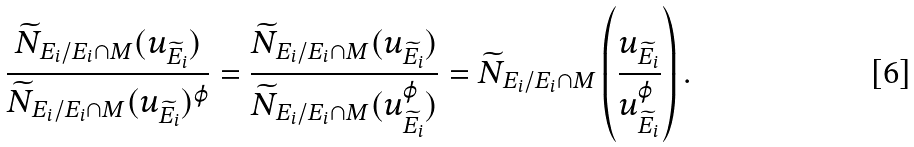<formula> <loc_0><loc_0><loc_500><loc_500>\frac { \widetilde { N } _ { E _ { i } / E _ { i } \cap M } ( u _ { \widetilde { E } _ { i } } ) } { \widetilde { N } _ { E _ { i } / E _ { i } \cap M } ( u _ { \widetilde { E } _ { i } } ) ^ { \varphi } } = \frac { \widetilde { N } _ { E _ { i } / E _ { i } \cap M } ( u _ { \widetilde { E } _ { i } } ) } { \widetilde { N } _ { E _ { i } / E _ { i } \cap M } ( u _ { \widetilde { E } _ { i } } ^ { \varphi } ) } = \widetilde { N } _ { E _ { i } / E _ { i } \cap M } \left ( \frac { u _ { \widetilde { E } _ { i } } } { u _ { \widetilde { E } _ { i } } ^ { \varphi } } \right ) .</formula> 